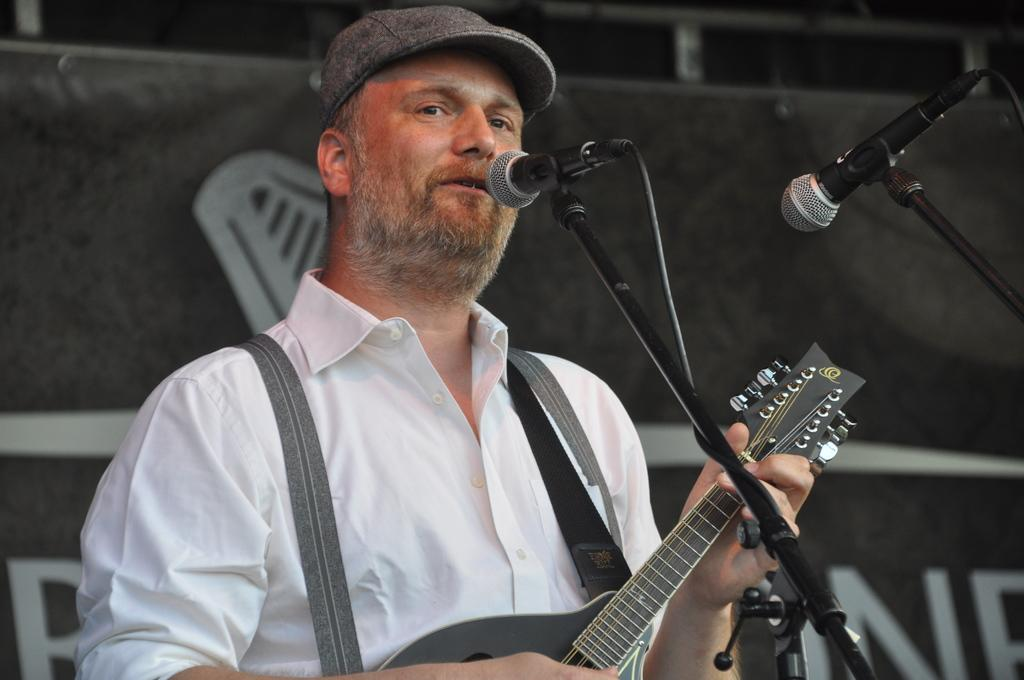What is the person in the image doing? The person in the image is holding a guitar. What objects are in front of the person? There are two microphones in front of the person. How many toes can be seen on the cow in the image? There is no cow present in the image, so it is not possible to determine the number of toes on a cow. 